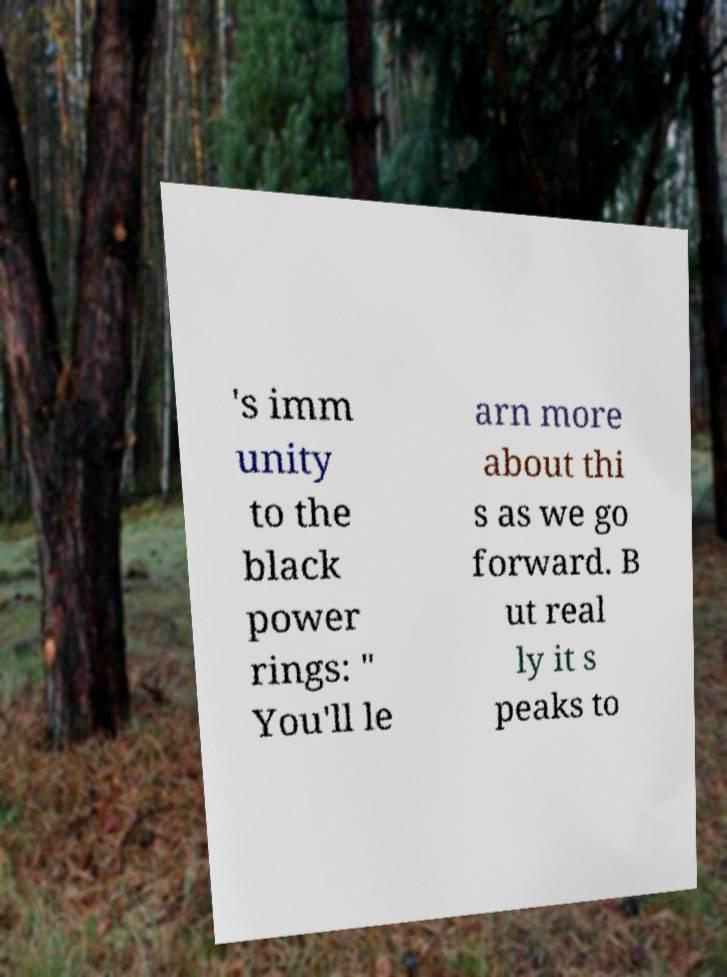For documentation purposes, I need the text within this image transcribed. Could you provide that? 's imm unity to the black power rings: " You'll le arn more about thi s as we go forward. B ut real ly it s peaks to 